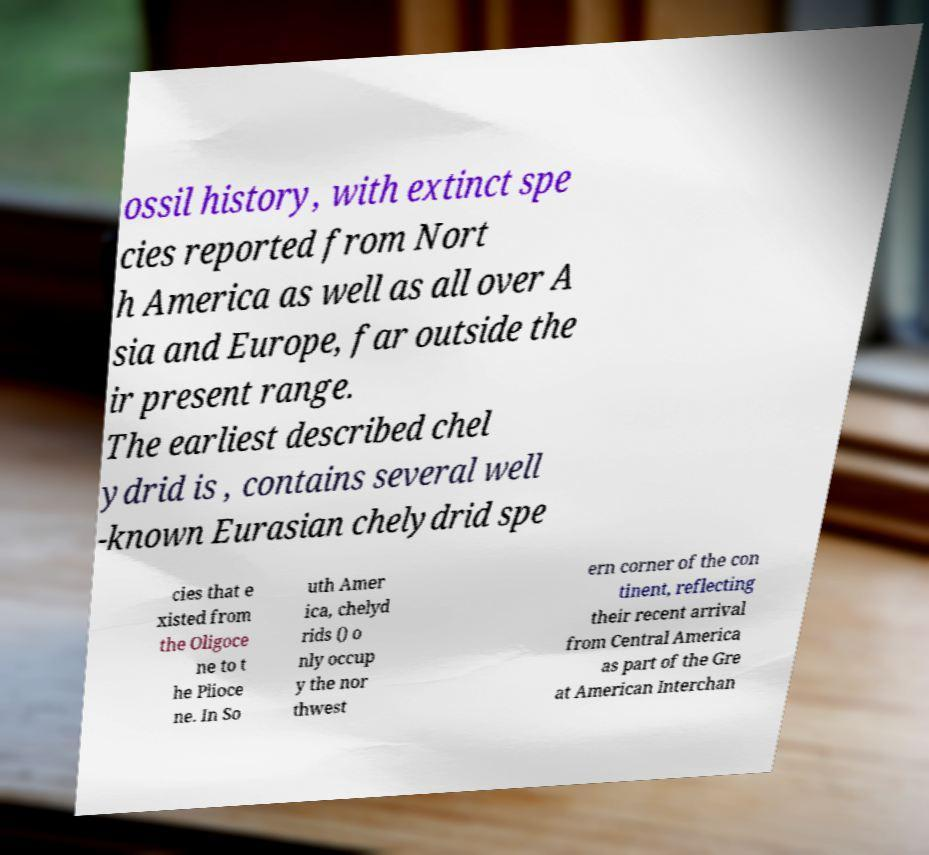Please identify and transcribe the text found in this image. ossil history, with extinct spe cies reported from Nort h America as well as all over A sia and Europe, far outside the ir present range. The earliest described chel ydrid is , contains several well -known Eurasian chelydrid spe cies that e xisted from the Oligoce ne to t he Plioce ne. In So uth Amer ica, chelyd rids () o nly occup y the nor thwest ern corner of the con tinent, reflecting their recent arrival from Central America as part of the Gre at American Interchan 